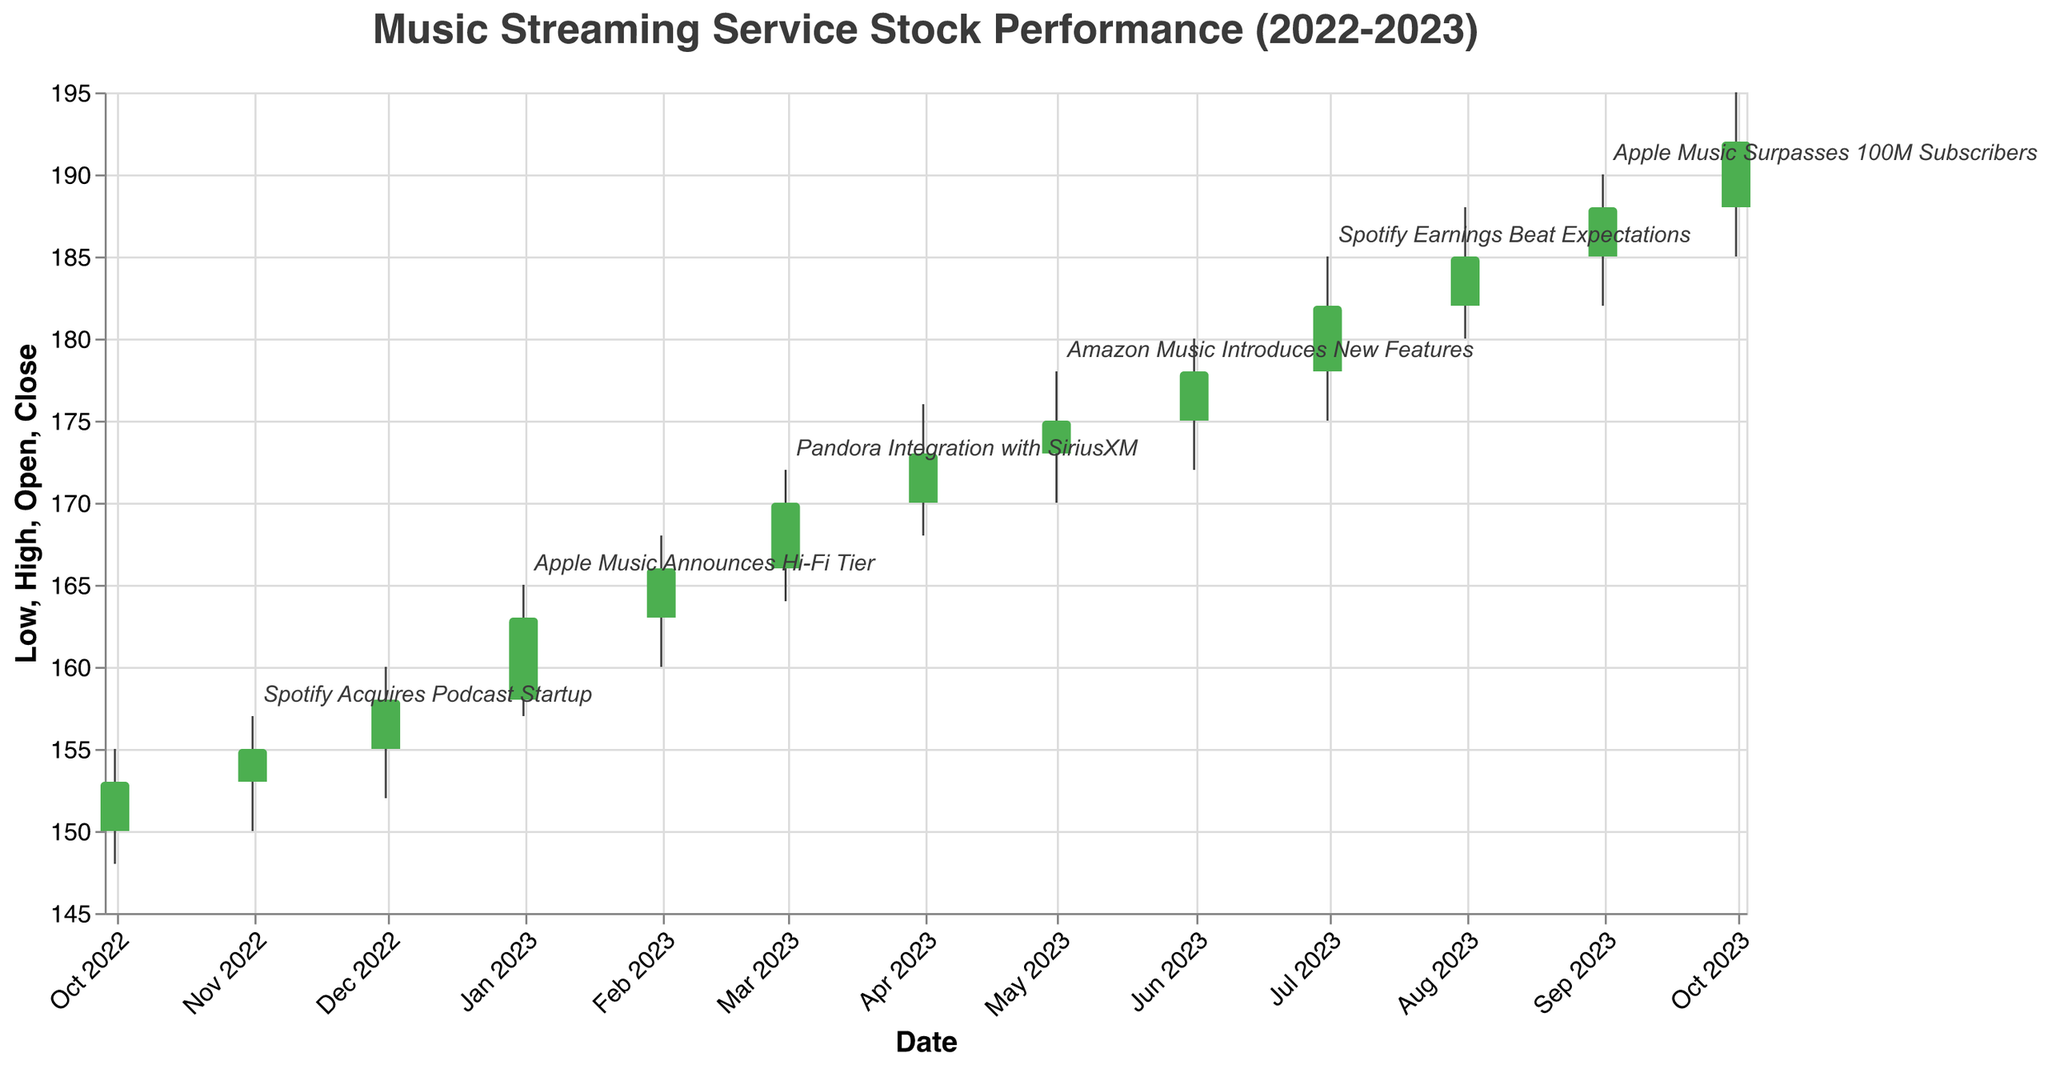Which event in the figure has the highest associated stock closing price? The highest closing price can be determined by finding the highest "Close" value in the figure and identifying the corresponding event. The highest closing price is $192.00 on October 1, 2023, and there is no event annotated for that date. Thus, the next highest closing price with an event is $188.00 on September 1, 2023, associated with "Apple Music Surpasses 100M Subscribers".
Answer: Apple Music Surpasses 100M Subscribers How did the stock price change in response to Spotify acquiring the podcast startup? Check the stock prices for the month before and the month after November 1, 2022, when the event occurred. The closing price increased from $153.00 (October) to $155.00 (November).
Answer: Increased What was the overall trend in the stock price over the year based on the candlestick plot? Identify the opening price at the beginning and the closing price at the end of the year. The opening price in October 2022 was $150.00, and the closing price in October 2023 was $192.00, indicating an upward trend.
Answer: Upward trend Which event in the plot is associated with the highest trading volume? The highest trading volume is 5,700,000 in October 2023. However, since there's no event for October 2023, we consider the next highest volume with an event, which is 5,600,000 for September 2023, associated with "Apple Music Surpasses 100M Subscribers".
Answer: Apple Music Surpasses 100M Subscribers Compare the stock performance before and after "Apple Music Announces Hi-Fi Tier". What can you infer? Compare the closing prices of December 2022 and January 2023. The price increased from $158.00 in December to $163.00 in January after "Apple Music Announces Hi-Fi Tier" on January 1, 2023, indicating a positive reaction.
Answer: Increased How many significant industry events are annotated in the plot? Count the number of data points with described "Event". There are six events annotated in the plot.
Answer: Six Among the annotated events, which event led to the largest monthly increase in the closing stock price? Calculate the monthly increase in closing prices for months when events occurred. The largest increase can be found between July 2023 and August 2023, when the price increased from $182.00 to $185.00 after "Spotify Earnings Beat Expectations".
Answer: Spotify Earnings Beat Expectations What is the closing stock price associated with the "Pandora Integration with SiriusXM" event? Refer to the closing price for March 1, 2023. The closing price is $170.00.
Answer: $170.00 